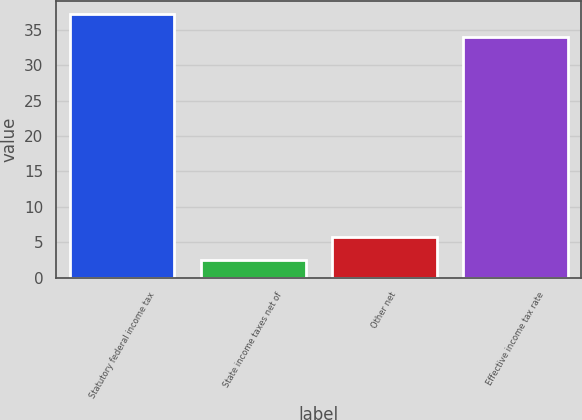<chart> <loc_0><loc_0><loc_500><loc_500><bar_chart><fcel>Statutory federal income tax<fcel>State income taxes net of<fcel>Other net<fcel>Effective income tax rate<nl><fcel>37.25<fcel>2.5<fcel>5.75<fcel>34<nl></chart> 